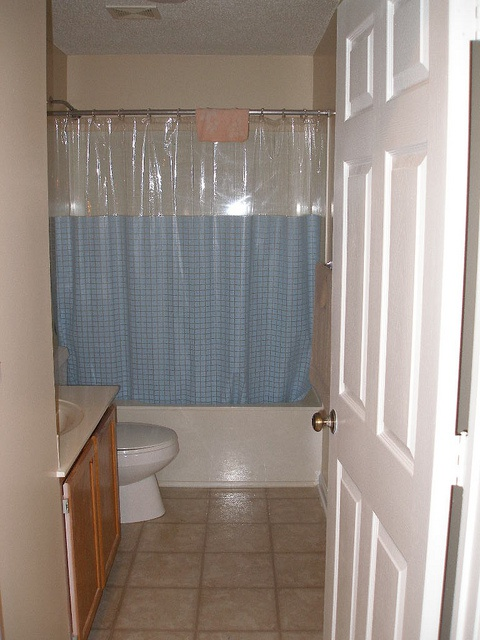Describe the objects in this image and their specific colors. I can see toilet in gray tones and sink in gray and maroon tones in this image. 